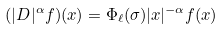<formula> <loc_0><loc_0><loc_500><loc_500>( | D | ^ { \alpha } f ) ( x ) = \Phi _ { \ell } ( \sigma ) | x | ^ { - \alpha } f ( x )</formula> 